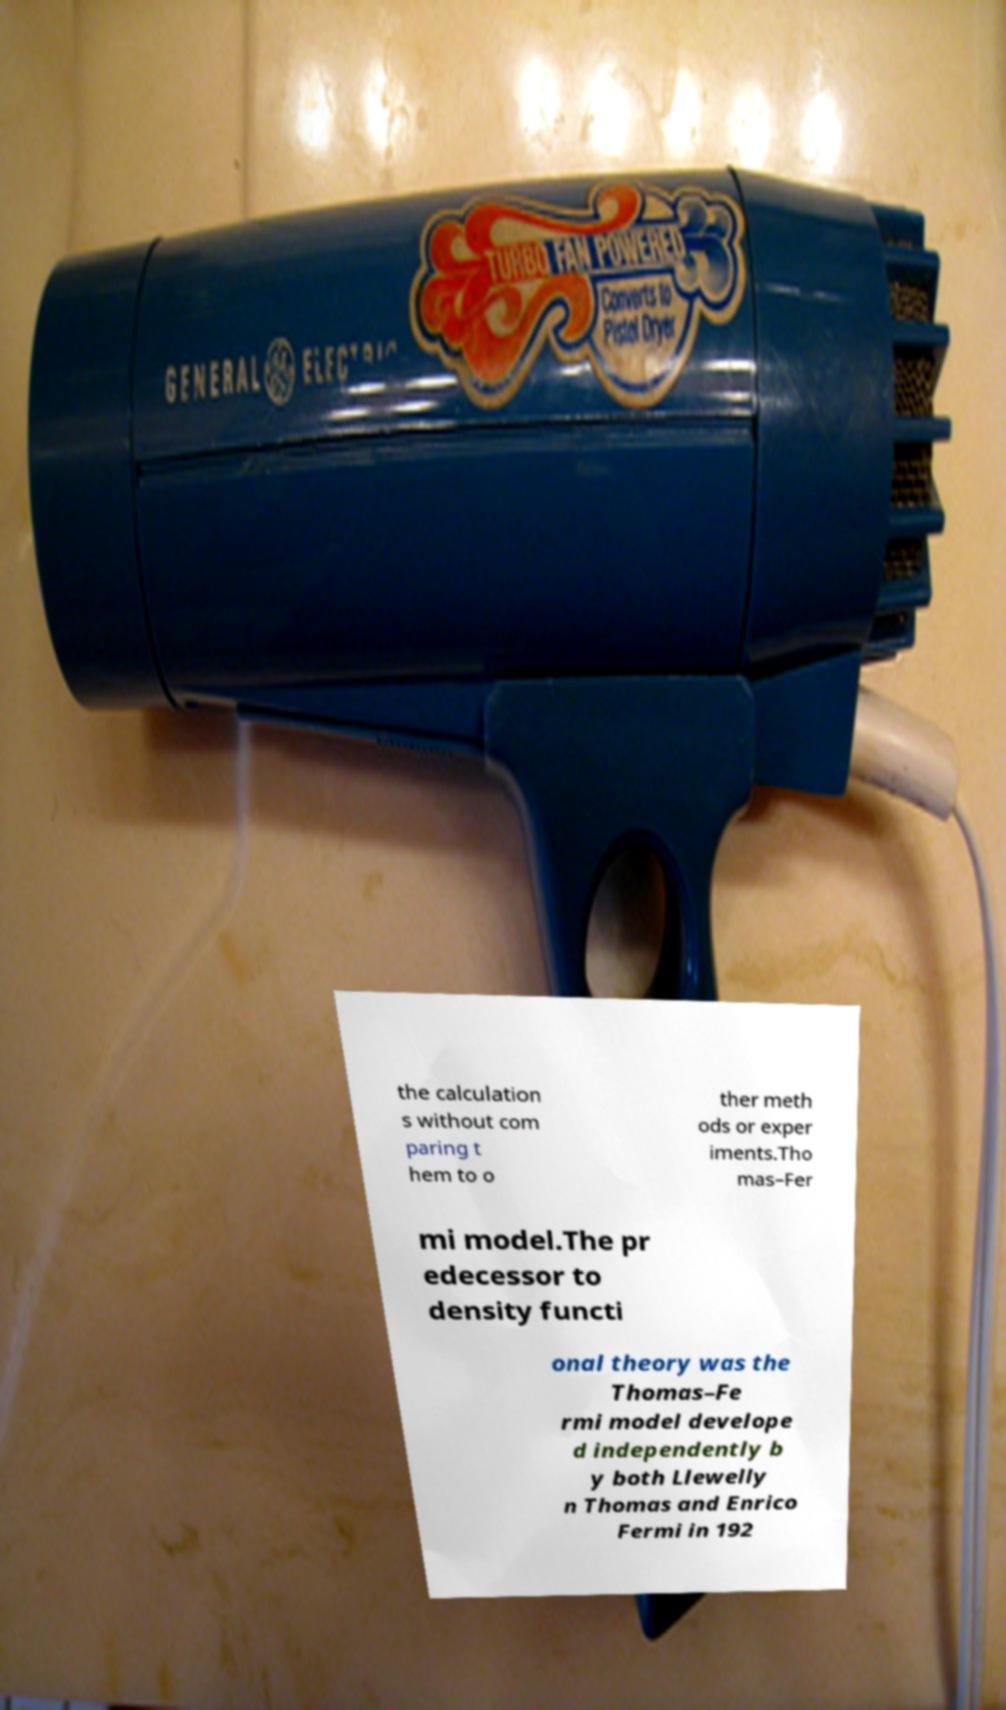For documentation purposes, I need the text within this image transcribed. Could you provide that? the calculation s without com paring t hem to o ther meth ods or exper iments.Tho mas–Fer mi model.The pr edecessor to density functi onal theory was the Thomas–Fe rmi model develope d independently b y both Llewelly n Thomas and Enrico Fermi in 192 